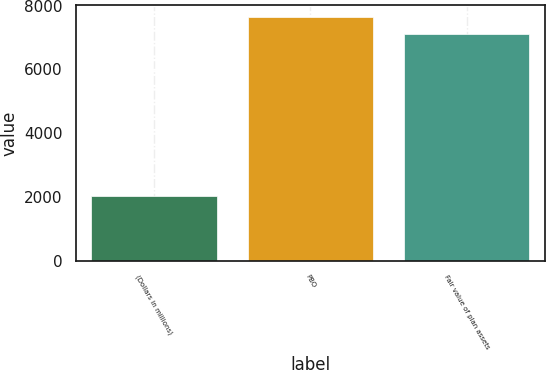<chart> <loc_0><loc_0><loc_500><loc_500><bar_chart><fcel>(Dollars in millions)<fcel>PBO<fcel>Fair value of plan assets<nl><fcel>2012<fcel>7629.9<fcel>7114<nl></chart> 